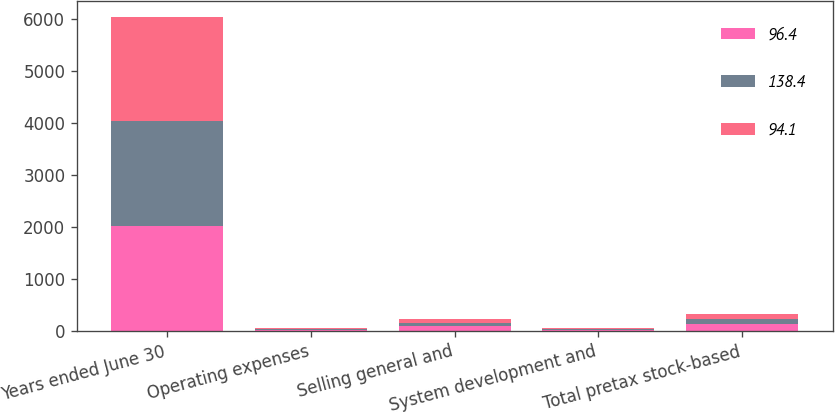Convert chart. <chart><loc_0><loc_0><loc_500><loc_500><stacked_bar_chart><ecel><fcel>Years ended June 30<fcel>Operating expenses<fcel>Selling general and<fcel>System development and<fcel>Total pretax stock-based<nl><fcel>96.4<fcel>2014<fcel>25.7<fcel>93.7<fcel>19<fcel>138.4<nl><fcel>138.4<fcel>2013<fcel>17.9<fcel>64<fcel>14.5<fcel>96.4<nl><fcel>94.1<fcel>2012<fcel>17.2<fcel>62.6<fcel>14.3<fcel>94.1<nl></chart> 